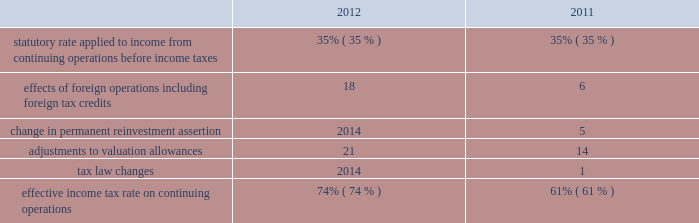Provision for income taxes increased $ 1791 million in 2012 from 2011 primarily due to the increase in pretax income from continuing operations , including the impact of the resumption of sales in libya in the first quarter of 2012 .
The following is an analysis of the effective income tax rates for 2012 and 2011: .
The effective income tax rate is influenced by a variety of factors including the geographic sources of income and the relative magnitude of these sources of income .
The provision for income taxes is allocated on a discrete , stand-alone basis to pretax segment income and to individual items not allocated to segments .
The difference between the total provision and the sum of the amounts allocated to segments appears in the "corporate and other unallocated items" shown in the reconciliation of segment income to net income below .
Effects of foreign operations 2013 the effects of foreign operations on our effective tax rate increased in 2012 as compared to 2011 , primarily due to the resumption of sales in libya in the first quarter of 2012 , where the statutory rate is in excess of 90 percent .
Change in permanent reinvestment assertion 2013 in the second quarter of 2011 , we recorded $ 716 million of deferred u.s .
Tax on undistributed earnings of $ 2046 million that we previously intended to permanently reinvest in foreign operations .
Offsetting this tax expense were associated foreign tax credits of $ 488 million .
In addition , we reduced our valuation allowance related to foreign tax credits by $ 228 million due to recognizing deferred u.s .
Tax on previously undistributed earnings .
Adjustments to valuation allowances 2013 in 2012 and 2011 , we increased the valuation allowance against foreign tax credits because it is more likely than not that we will be unable to realize all u.s .
Benefits on foreign taxes accrued in those years .
See item 8 .
Financial statements and supplementary data - note 10 to the consolidated financial statements for further information about income taxes .
Discontinued operations is presented net of tax , and reflects our downstream business that was spun off june 30 , 2011 and our angola business which we agreed to sell in 2013 .
See item 8 .
Financial statements and supplementary data 2013 notes 3 and 6 to the consolidated financial statements for additional information. .
By how much did the effective income tax rate on continuing operations increase from 2011 to 2012? 
Computations: (74% - 61%)
Answer: 0.13. 